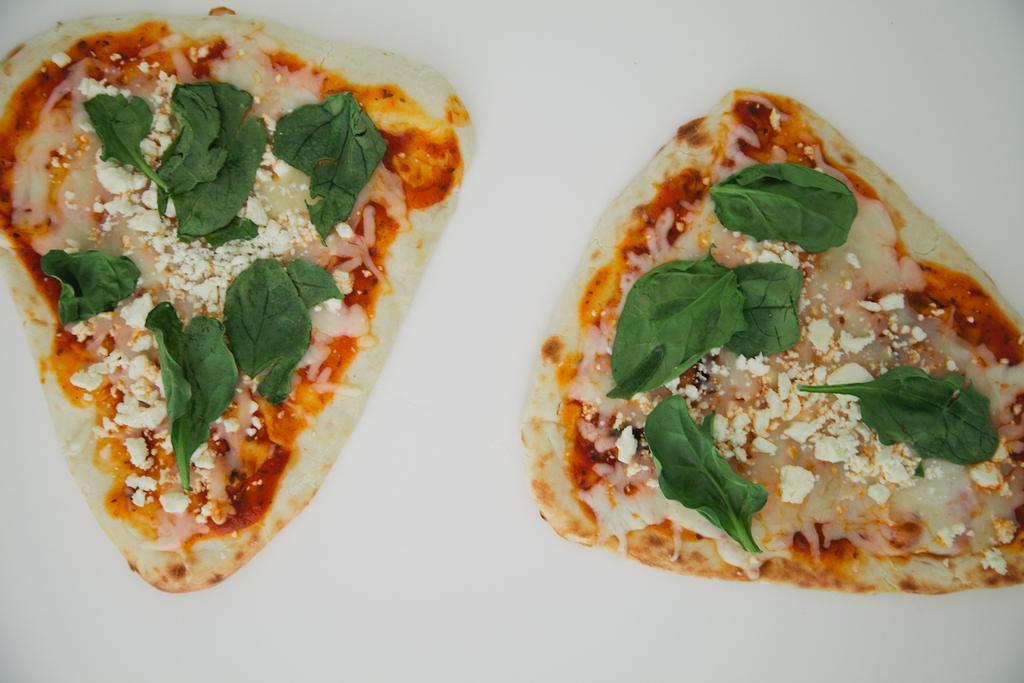Can you describe this image briefly? In this picture I can observe some food placed on the white color surface. The food is in cream, green and brown color. 